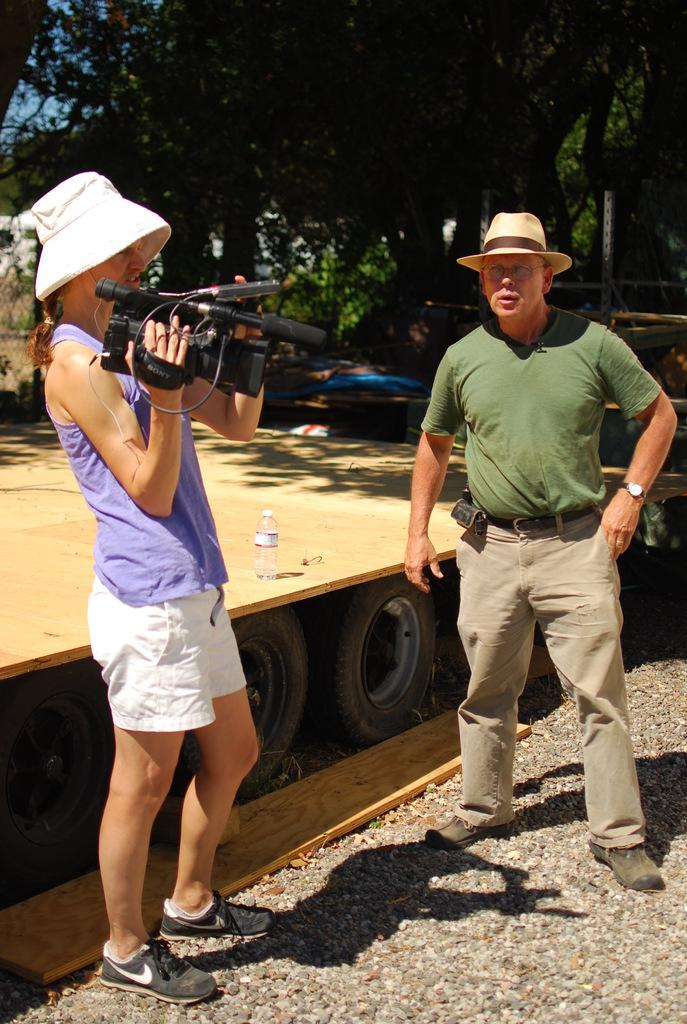How many people are in the image? There are two people in the image. What are the people doing in the image? The people are standing on the ground. Can you describe what one of the people is holding? One of the people is holding a camera. What can be seen in the background of the image? There is a wooden stage and trees in the background. What type of underwear is the person wearing in the image? There is no information about the person's underwear in the image, and therefore it cannot be determined. Can you tell me if there is a pet visible in the image? There is no pet present in the image. 